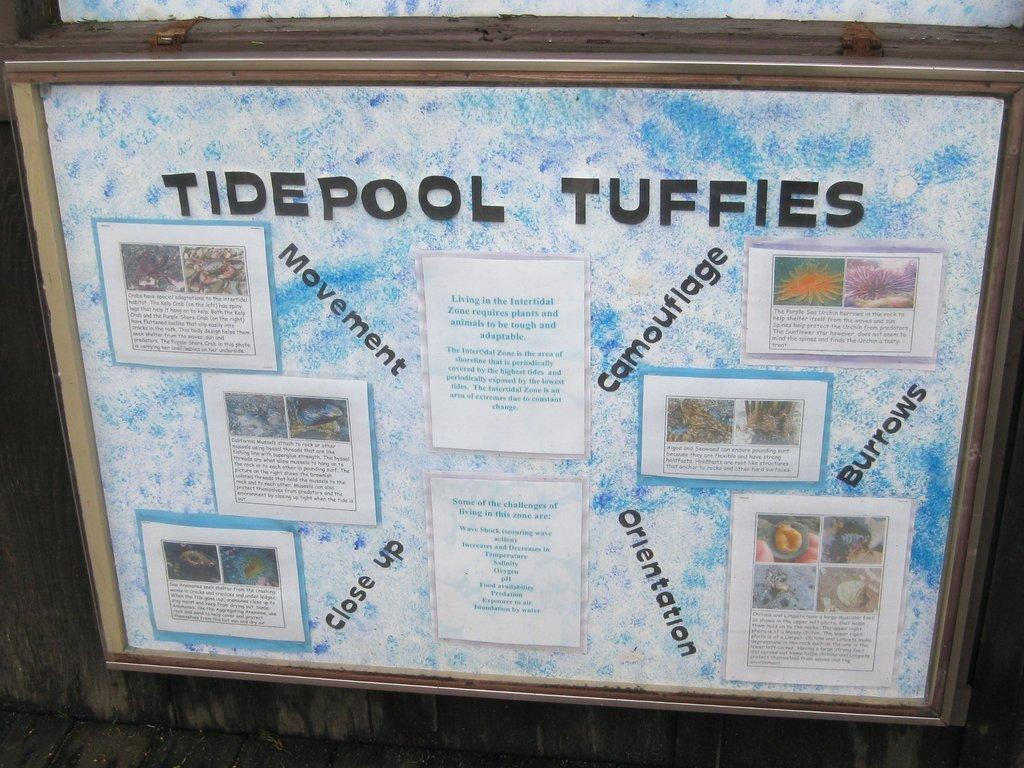<image>
Describe the image concisely. A board with different articles posted on it titled Tide pol Tuffies on the top of it. 